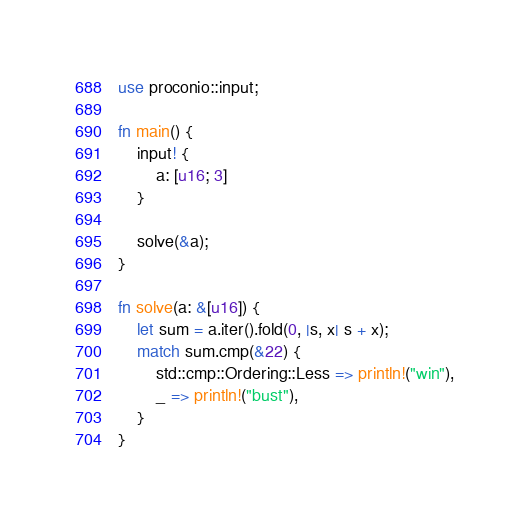<code> <loc_0><loc_0><loc_500><loc_500><_Rust_>use proconio::input;

fn main() {
    input! {
        a: [u16; 3]
    }

    solve(&a);
}

fn solve(a: &[u16]) {
    let sum = a.iter().fold(0, |s, x| s + x);
    match sum.cmp(&22) {
        std::cmp::Ordering::Less => println!("win"),
        _ => println!("bust"),
    }
}
</code> 